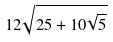<formula> <loc_0><loc_0><loc_500><loc_500>1 2 \sqrt { 2 5 + 1 0 \sqrt { 5 } }</formula> 